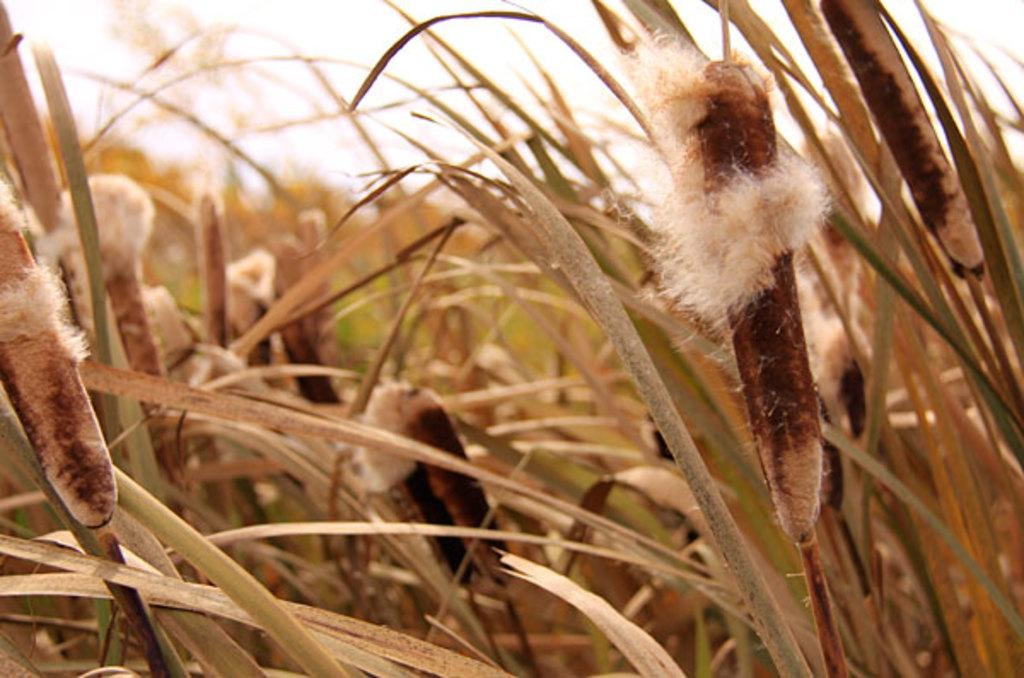What type of plants are in the image? There are cotton plants in the image. What part of the plants can be seen in the image? The plants have leaves at the bottom. What is visible at the top of the image? The sky is visible at the top of the image. Can you describe the background of the image? The background of the image is blurred. How many birds can be seen flying over the lake in the image? There are no birds or lake present in the image; it features cotton plants with leaves and a blurred background. 